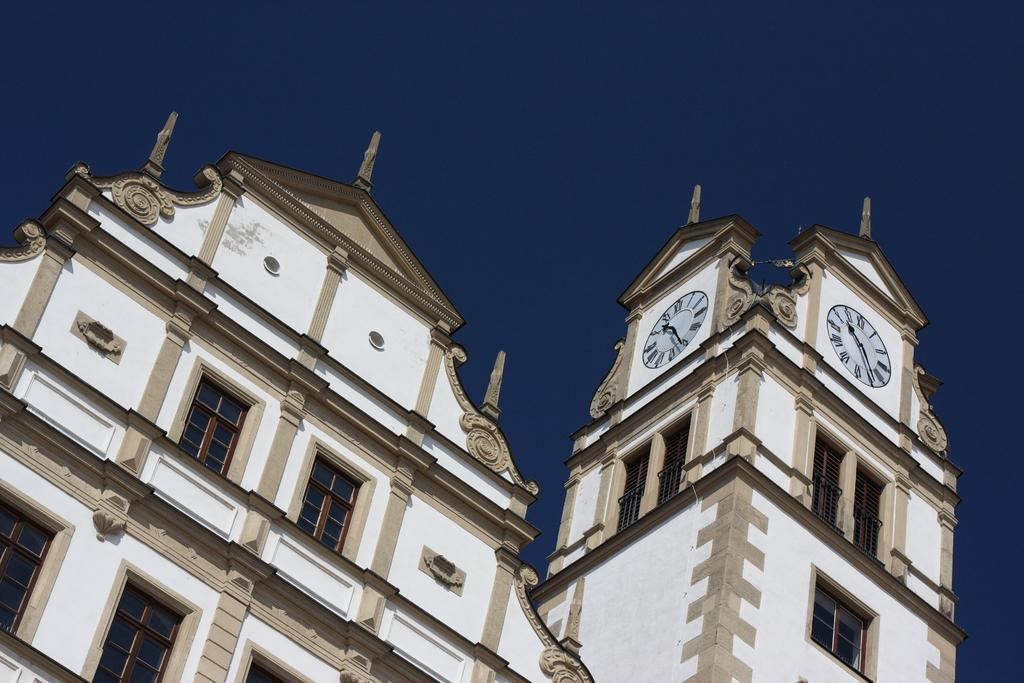What type of structures can be seen in the image? There are buildings in the image. What type of offer is being made by the cabbage in the image? There is no cabbage present in the image, and therefore no offer can be made by it. 